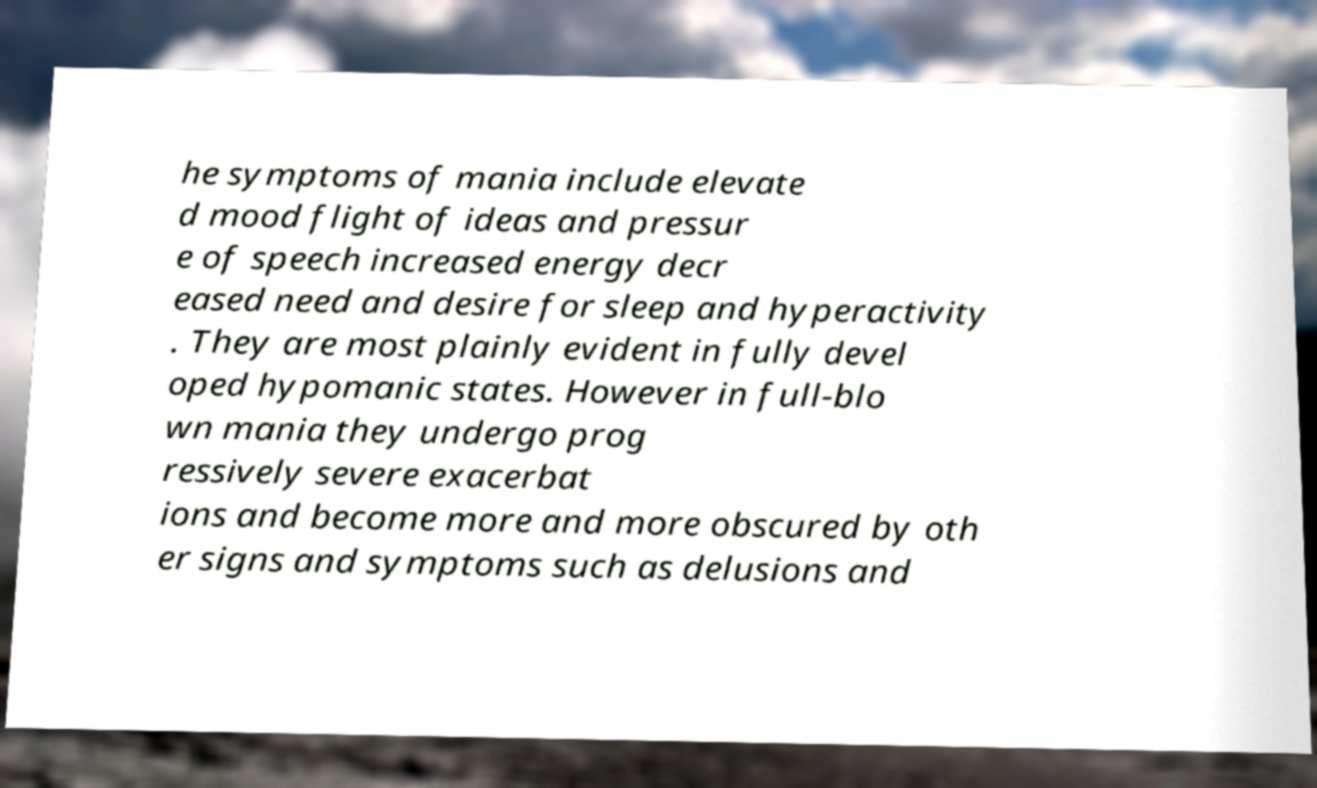Could you extract and type out the text from this image? he symptoms of mania include elevate d mood flight of ideas and pressur e of speech increased energy decr eased need and desire for sleep and hyperactivity . They are most plainly evident in fully devel oped hypomanic states. However in full-blo wn mania they undergo prog ressively severe exacerbat ions and become more and more obscured by oth er signs and symptoms such as delusions and 